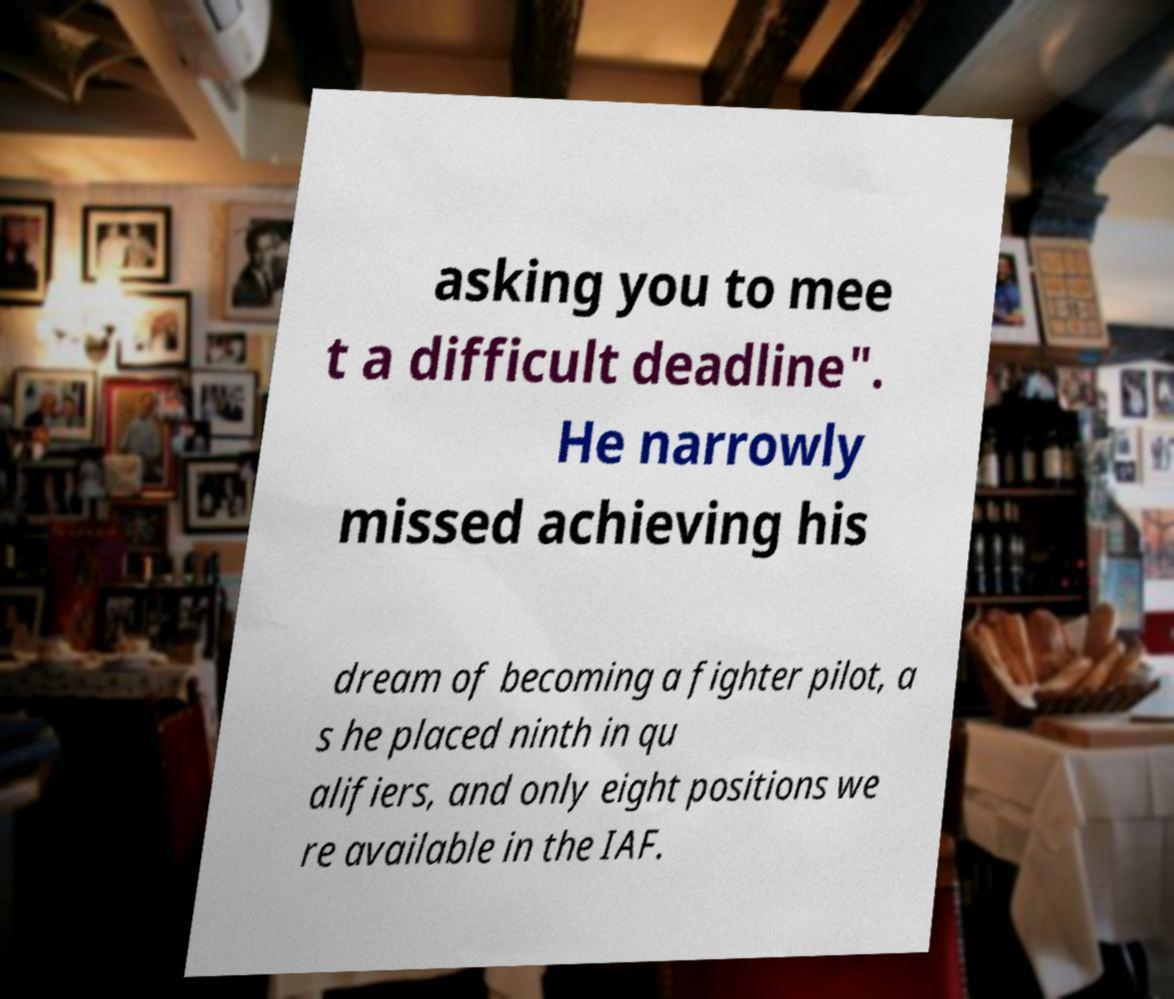What messages or text are displayed in this image? I need them in a readable, typed format. asking you to mee t a difficult deadline". He narrowly missed achieving his dream of becoming a fighter pilot, a s he placed ninth in qu alifiers, and only eight positions we re available in the IAF. 